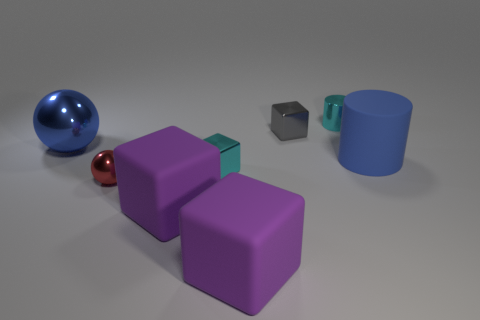There is a tiny shiny cube to the right of the small cyan metal block; how many small shiny objects are to the left of it?
Keep it short and to the point. 2. There is a large blue thing right of the tiny sphere; does it have the same shape as the small cyan shiny thing that is in front of the blue metallic thing?
Provide a short and direct response. No. How many things are both behind the small red shiny thing and on the left side of the rubber cylinder?
Provide a short and direct response. 4. Is there a big block of the same color as the small cylinder?
Provide a short and direct response. No. There is a red shiny object that is the same size as the cyan metallic block; what shape is it?
Offer a very short reply. Sphere. There is a big sphere; are there any small cyan shiny objects to the left of it?
Provide a succinct answer. No. Is the big blue object to the left of the red sphere made of the same material as the small block in front of the blue rubber cylinder?
Make the answer very short. Yes. How many other blue matte cylinders are the same size as the blue cylinder?
Provide a succinct answer. 0. There is another big thing that is the same color as the large shiny object; what is its shape?
Make the answer very short. Cylinder. What is the material of the ball that is to the right of the big metallic object?
Your answer should be compact. Metal. 